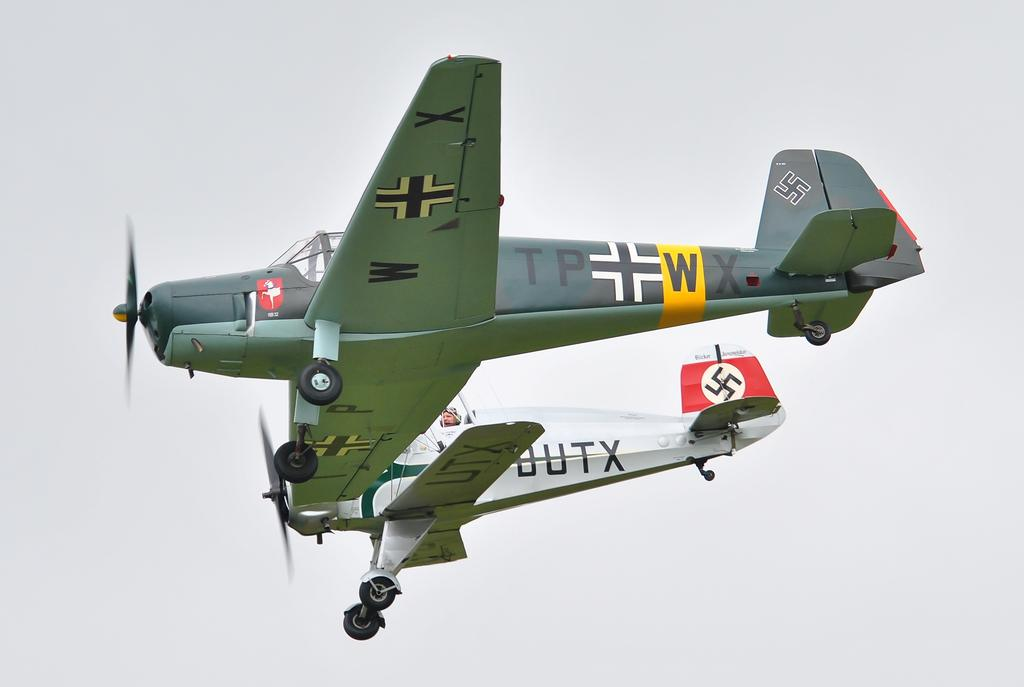<image>
Provide a brief description of the given image. An airplane with a W and X under the wing is next to an airplane with UTX under the wing. 